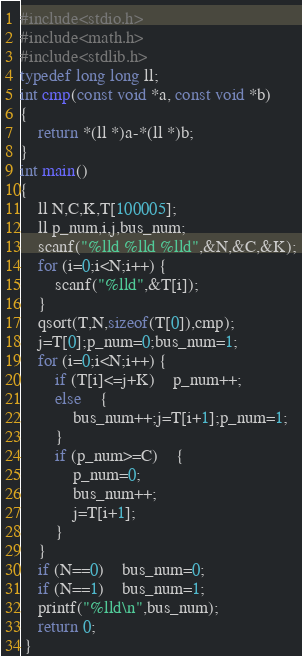<code> <loc_0><loc_0><loc_500><loc_500><_C_>#include<stdio.h>
#include<math.h>
#include<stdlib.h>
typedef long long ll;
int cmp(const void *a, const void *b)
{
	return *(ll *)a-*(ll *)b;
}
int main()
{
	ll N,C,K,T[100005];
	ll p_num,i,j,bus_num;
	scanf("%lld %lld %lld",&N,&C,&K);
	for (i=0;i<N;i++) {
		scanf("%lld",&T[i]);
	}
	qsort(T,N,sizeof(T[0]),cmp);
	j=T[0];p_num=0;bus_num=1;
	for (i=0;i<N;i++) {
		if (T[i]<=j+K)	p_num++;
		else	{
			bus_num++;j=T[i+1];p_num=1;
		}
		if (p_num>=C)	{
			p_num=0;
			bus_num++;
			j=T[i+1];
		}
	}
	if (N==0)	bus_num=0;
	if (N==1)	bus_num=1;
	printf("%lld\n",bus_num);
	return 0;
 } </code> 